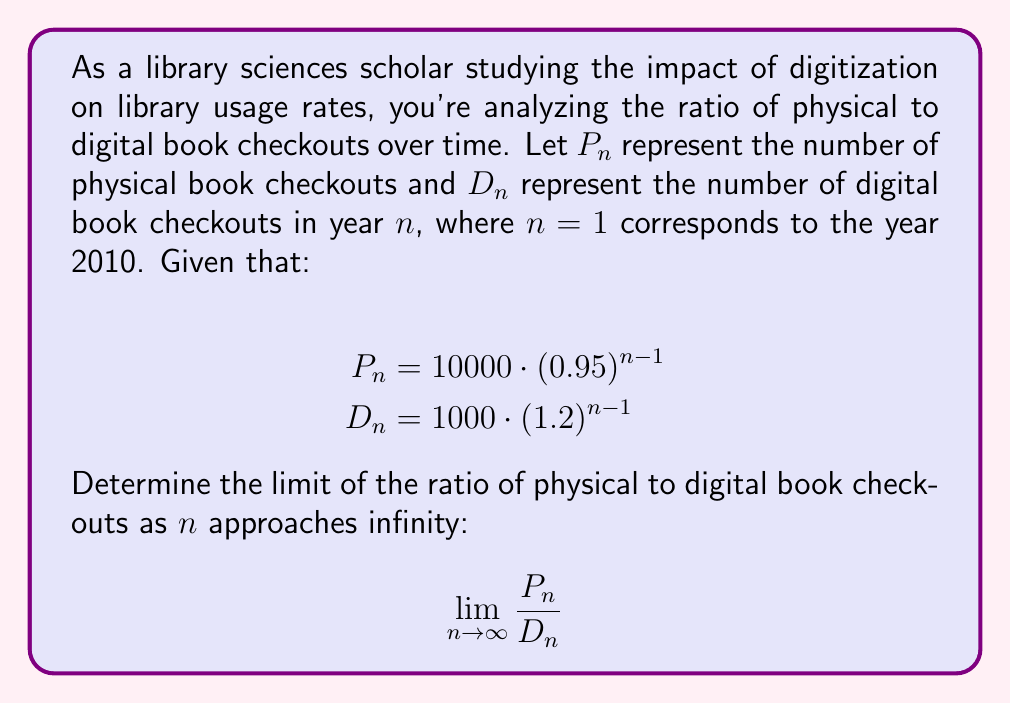Can you answer this question? To solve this problem, we'll use the limit comparison test. Let's follow these steps:

1) First, let's write out the ratio of $P_n$ to $D_n$:

   $$\frac{P_n}{D_n} = \frac{10000 \cdot (0.95)^{n-1}}{1000 \cdot (1.2)^{n-1}}$$

2) Simplify the fraction:

   $$\frac{P_n}{D_n} = 10 \cdot \left(\frac{0.95}{1.2}\right)^{n-1}$$

3) Let's calculate the value inside the parentheses:

   $$\frac{0.95}{1.2} \approx 0.7917$$

4) Now our ratio looks like this:

   $$\frac{P_n}{D_n} = 10 \cdot (0.7917)^{n-1}$$

5) As $n$ approaches infinity, $(0.7917)^{n-1}$ will approach 0, because 0.7917 is less than 1.

6) Therefore:

   $$\lim_{n \to \infty} \frac{P_n}{D_n} = \lim_{n \to \infty} 10 \cdot (0.7917)^{n-1} = 10 \cdot 0 = 0$$

This result indicates that as time goes on, the number of physical book checkouts will become negligible compared to digital book checkouts.
Answer: The limit of the ratio of physical to digital book checkouts as $n$ approaches infinity is 0. 